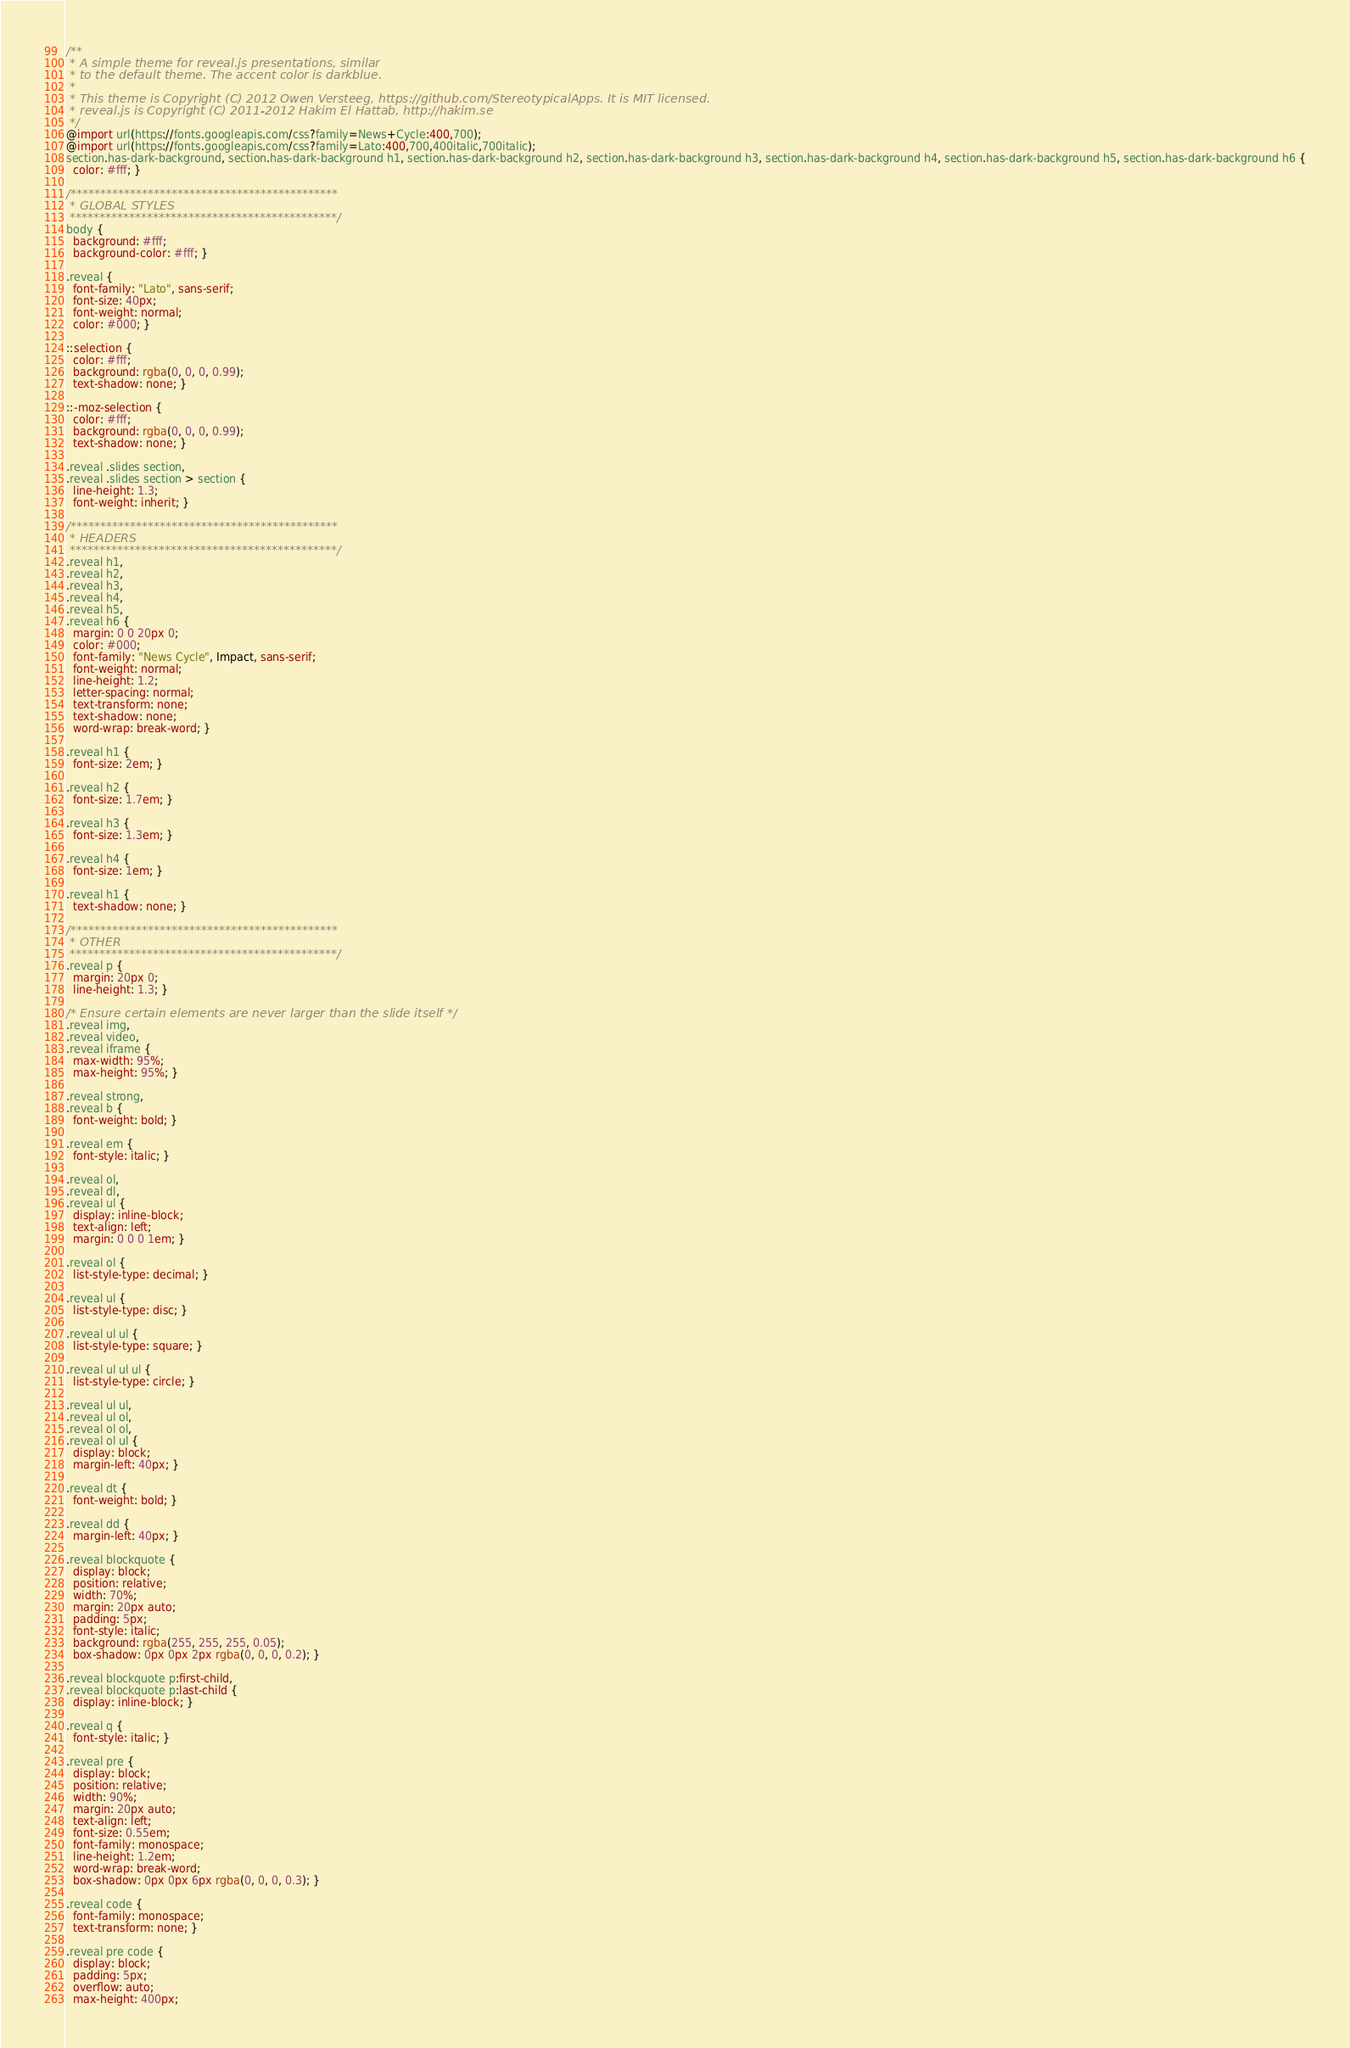<code> <loc_0><loc_0><loc_500><loc_500><_CSS_>/**
 * A simple theme for reveal.js presentations, similar
 * to the default theme. The accent color is darkblue.
 *
 * This theme is Copyright (C) 2012 Owen Versteeg, https://github.com/StereotypicalApps. It is MIT licensed.
 * reveal.js is Copyright (C) 2011-2012 Hakim El Hattab, http://hakim.se
 */
@import url(https://fonts.googleapis.com/css?family=News+Cycle:400,700);
@import url(https://fonts.googleapis.com/css?family=Lato:400,700,400italic,700italic);
section.has-dark-background, section.has-dark-background h1, section.has-dark-background h2, section.has-dark-background h3, section.has-dark-background h4, section.has-dark-background h5, section.has-dark-background h6 {
  color: #fff; }

/*********************************************
 * GLOBAL STYLES
 *********************************************/
body {
  background: #fff;
  background-color: #fff; }

.reveal {
  font-family: "Lato", sans-serif;
  font-size: 40px;
  font-weight: normal;
  color: #000; }

::selection {
  color: #fff;
  background: rgba(0, 0, 0, 0.99);
  text-shadow: none; }

::-moz-selection {
  color: #fff;
  background: rgba(0, 0, 0, 0.99);
  text-shadow: none; }

.reveal .slides section,
.reveal .slides section > section {
  line-height: 1.3;
  font-weight: inherit; }

/*********************************************
 * HEADERS
 *********************************************/
.reveal h1,
.reveal h2,
.reveal h3,
.reveal h4,
.reveal h5,
.reveal h6 {
  margin: 0 0 20px 0;
  color: #000;
  font-family: "News Cycle", Impact, sans-serif;
  font-weight: normal;
  line-height: 1.2;
  letter-spacing: normal;
  text-transform: none;
  text-shadow: none;
  word-wrap: break-word; }

.reveal h1 {
  font-size: 2em; }

.reveal h2 {
  font-size: 1.7em; }

.reveal h3 {
  font-size: 1.3em; }

.reveal h4 {
  font-size: 1em; }

.reveal h1 {
  text-shadow: none; }

/*********************************************
 * OTHER
 *********************************************/
.reveal p {
  margin: 20px 0;
  line-height: 1.3; }

/* Ensure certain elements are never larger than the slide itself */
.reveal img,
.reveal video,
.reveal iframe {
  max-width: 95%;
  max-height: 95%; }

.reveal strong,
.reveal b {
  font-weight: bold; }

.reveal em {
  font-style: italic; }

.reveal ol,
.reveal dl,
.reveal ul {
  display: inline-block;
  text-align: left;
  margin: 0 0 0 1em; }

.reveal ol {
  list-style-type: decimal; }

.reveal ul {
  list-style-type: disc; }

.reveal ul ul {
  list-style-type: square; }

.reveal ul ul ul {
  list-style-type: circle; }

.reveal ul ul,
.reveal ul ol,
.reveal ol ol,
.reveal ol ul {
  display: block;
  margin-left: 40px; }

.reveal dt {
  font-weight: bold; }

.reveal dd {
  margin-left: 40px; }

.reveal blockquote {
  display: block;
  position: relative;
  width: 70%;
  margin: 20px auto;
  padding: 5px;
  font-style: italic;
  background: rgba(255, 255, 255, 0.05);
  box-shadow: 0px 0px 2px rgba(0, 0, 0, 0.2); }

.reveal blockquote p:first-child,
.reveal blockquote p:last-child {
  display: inline-block; }

.reveal q {
  font-style: italic; }

.reveal pre {
  display: block;
  position: relative;
  width: 90%;
  margin: 20px auto;
  text-align: left;
  font-size: 0.55em;
  font-family: monospace;
  line-height: 1.2em;
  word-wrap: break-word;
  box-shadow: 0px 0px 6px rgba(0, 0, 0, 0.3); }

.reveal code {
  font-family: monospace;
  text-transform: none; }

.reveal pre code {
  display: block;
  padding: 5px;
  overflow: auto;
  max-height: 400px;</code> 